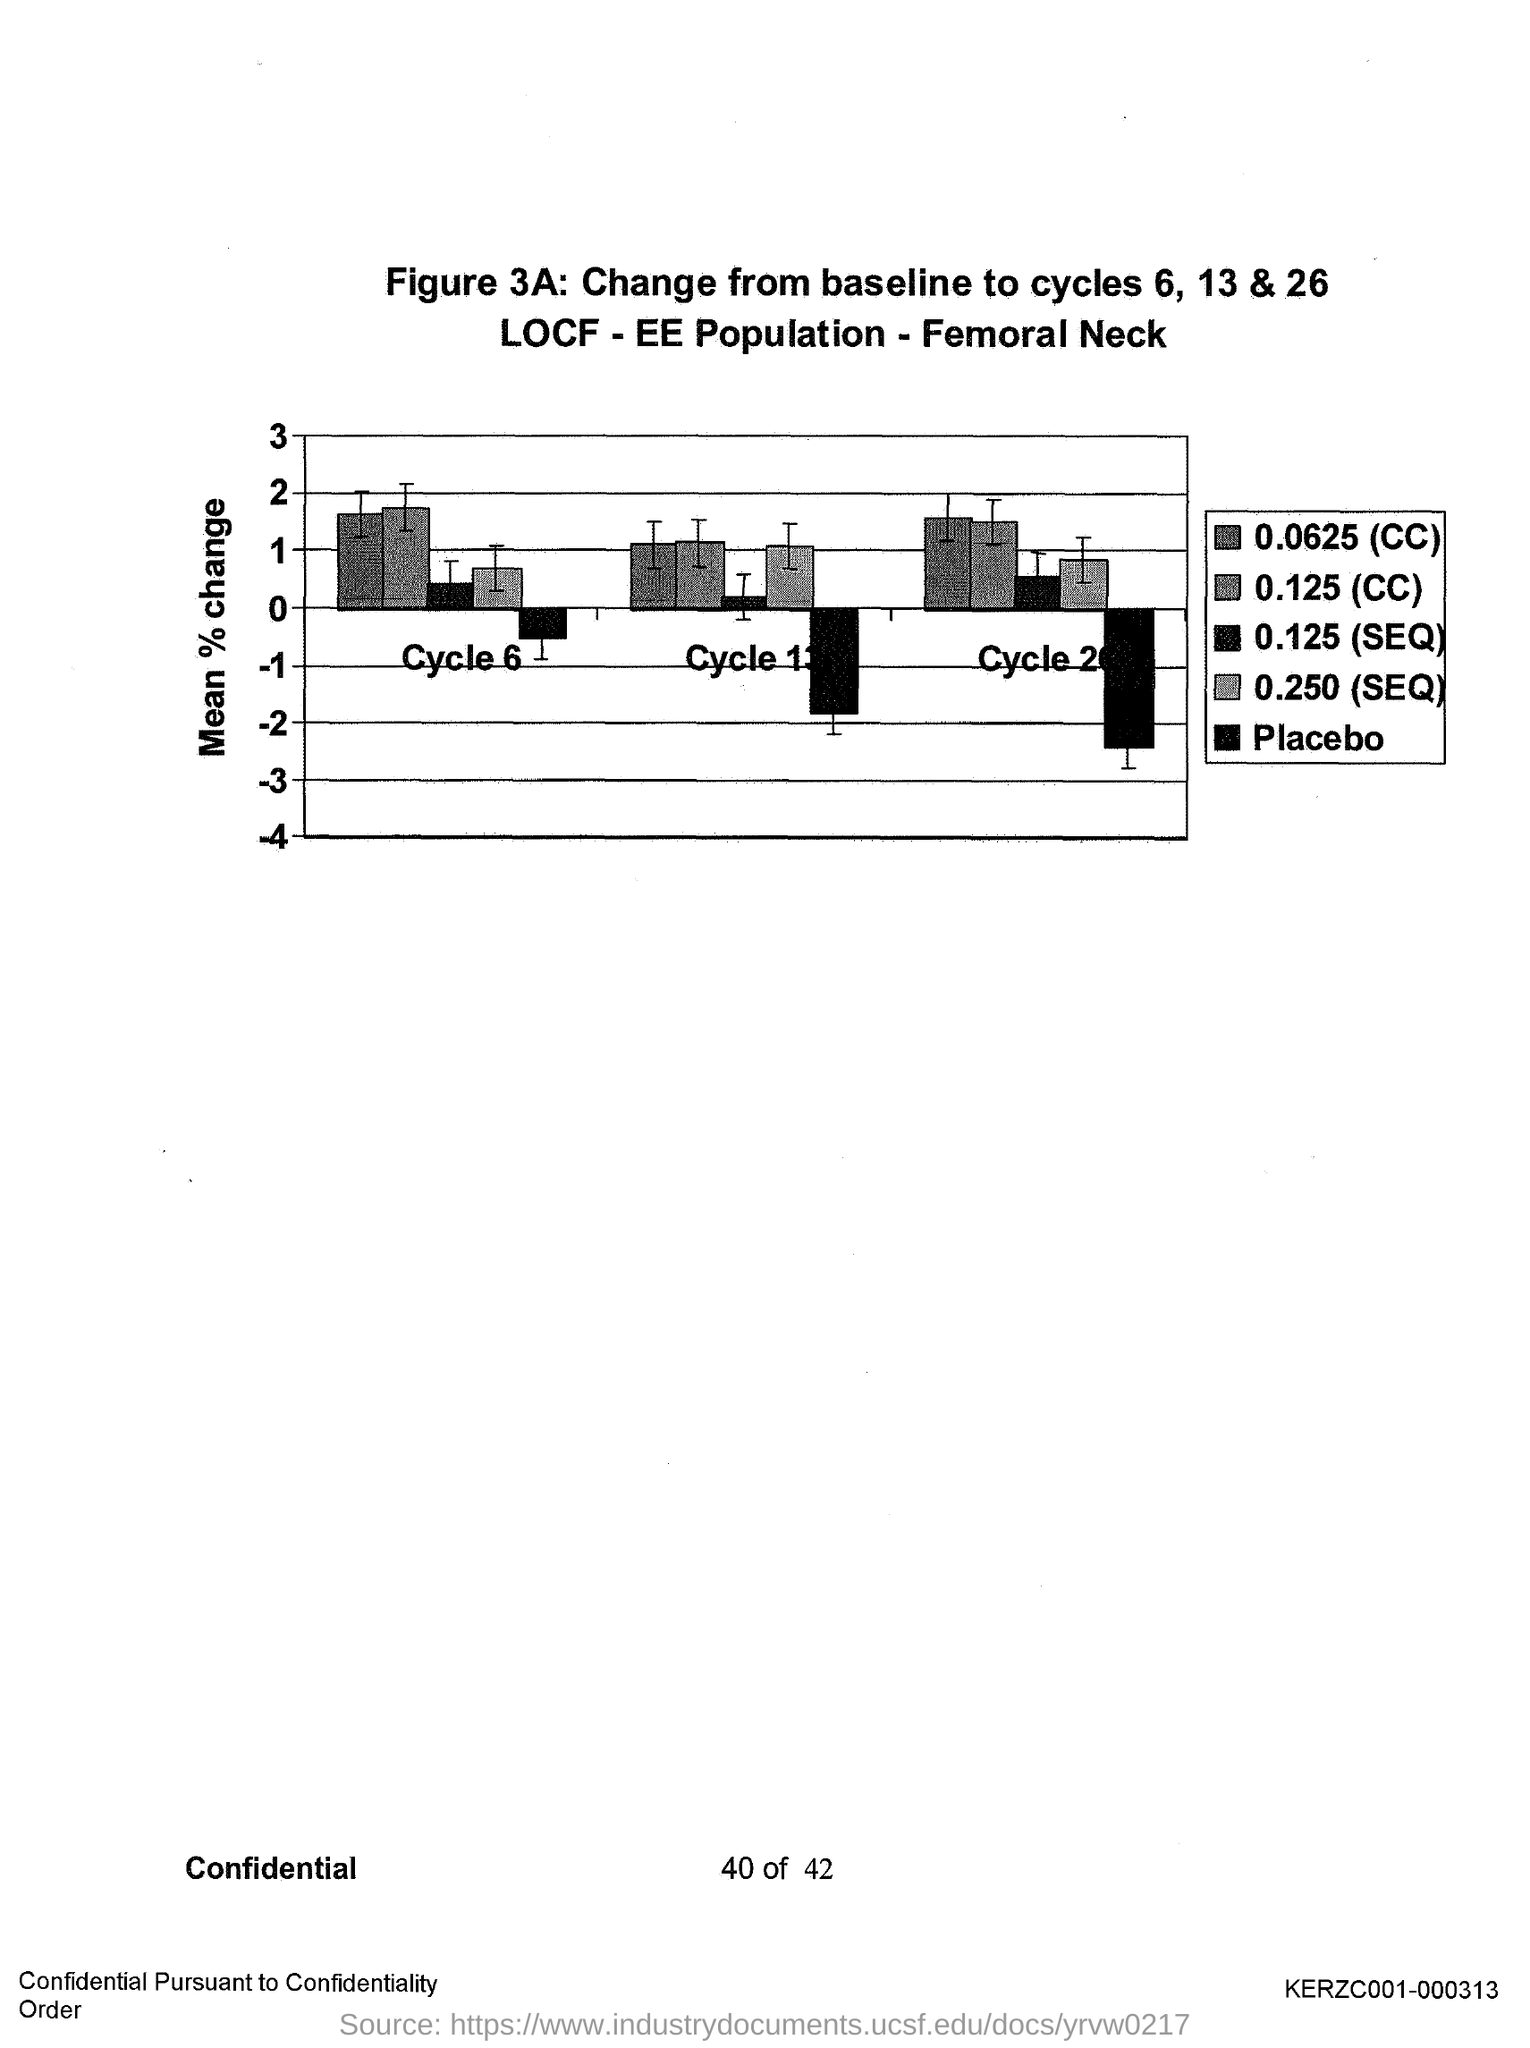Outline some significant characteristics in this image. The y-axis in the graph represents the mean percentage change in the number of shares traded per trade for each exchange over the study period, indicating the average change in the number of shares traded per trade for each exchange over time. 